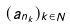<formula> <loc_0><loc_0><loc_500><loc_500>( a _ { n _ { k } } ) _ { k \in N }</formula> 